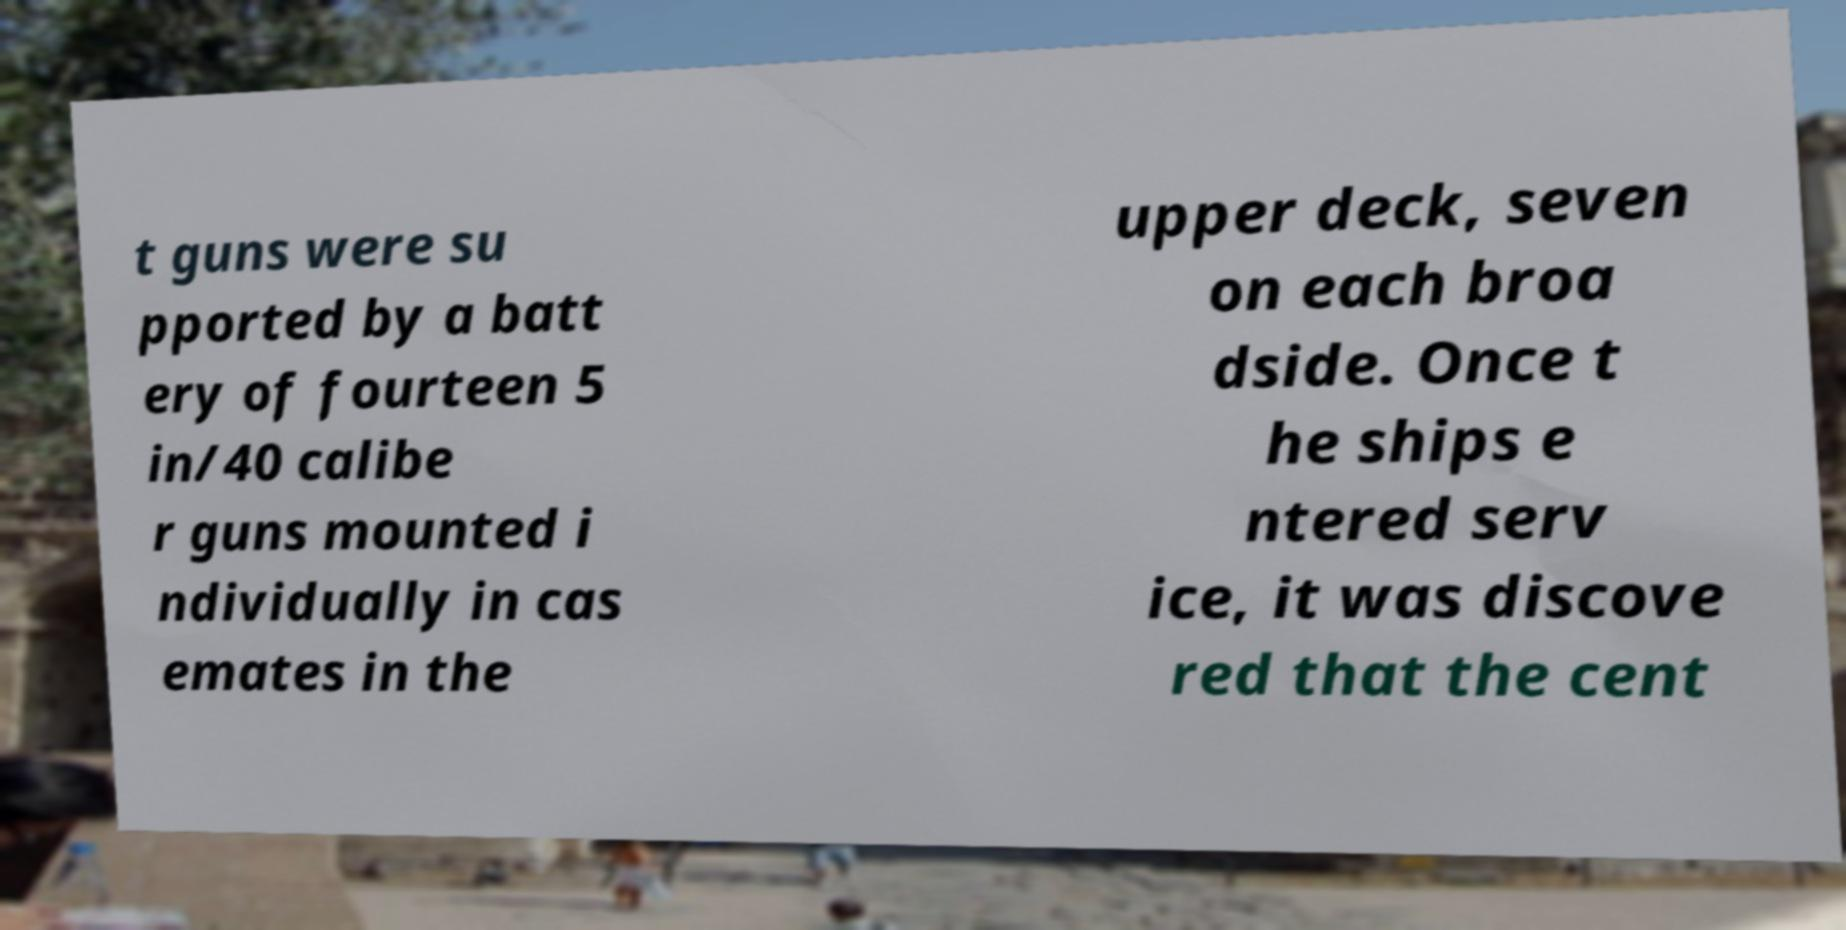Can you read and provide the text displayed in the image?This photo seems to have some interesting text. Can you extract and type it out for me? t guns were su pported by a batt ery of fourteen 5 in/40 calibe r guns mounted i ndividually in cas emates in the upper deck, seven on each broa dside. Once t he ships e ntered serv ice, it was discove red that the cent 